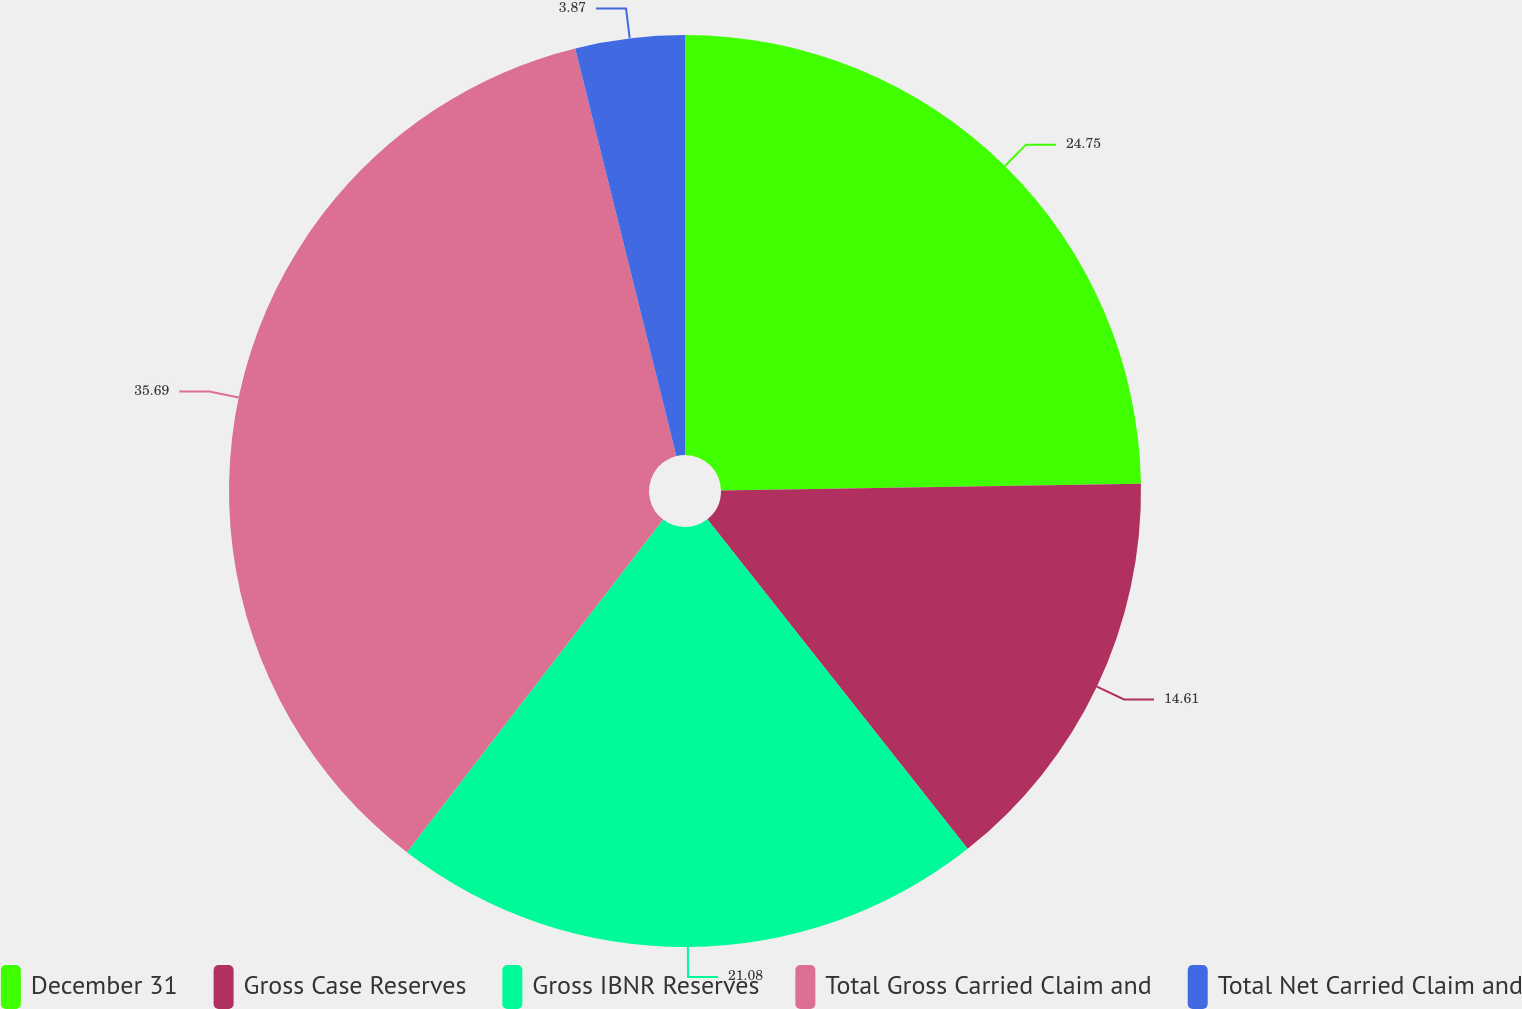Convert chart to OTSL. <chart><loc_0><loc_0><loc_500><loc_500><pie_chart><fcel>December 31<fcel>Gross Case Reserves<fcel>Gross IBNR Reserves<fcel>Total Gross Carried Claim and<fcel>Total Net Carried Claim and<nl><fcel>24.75%<fcel>14.61%<fcel>21.08%<fcel>35.69%<fcel>3.87%<nl></chart> 